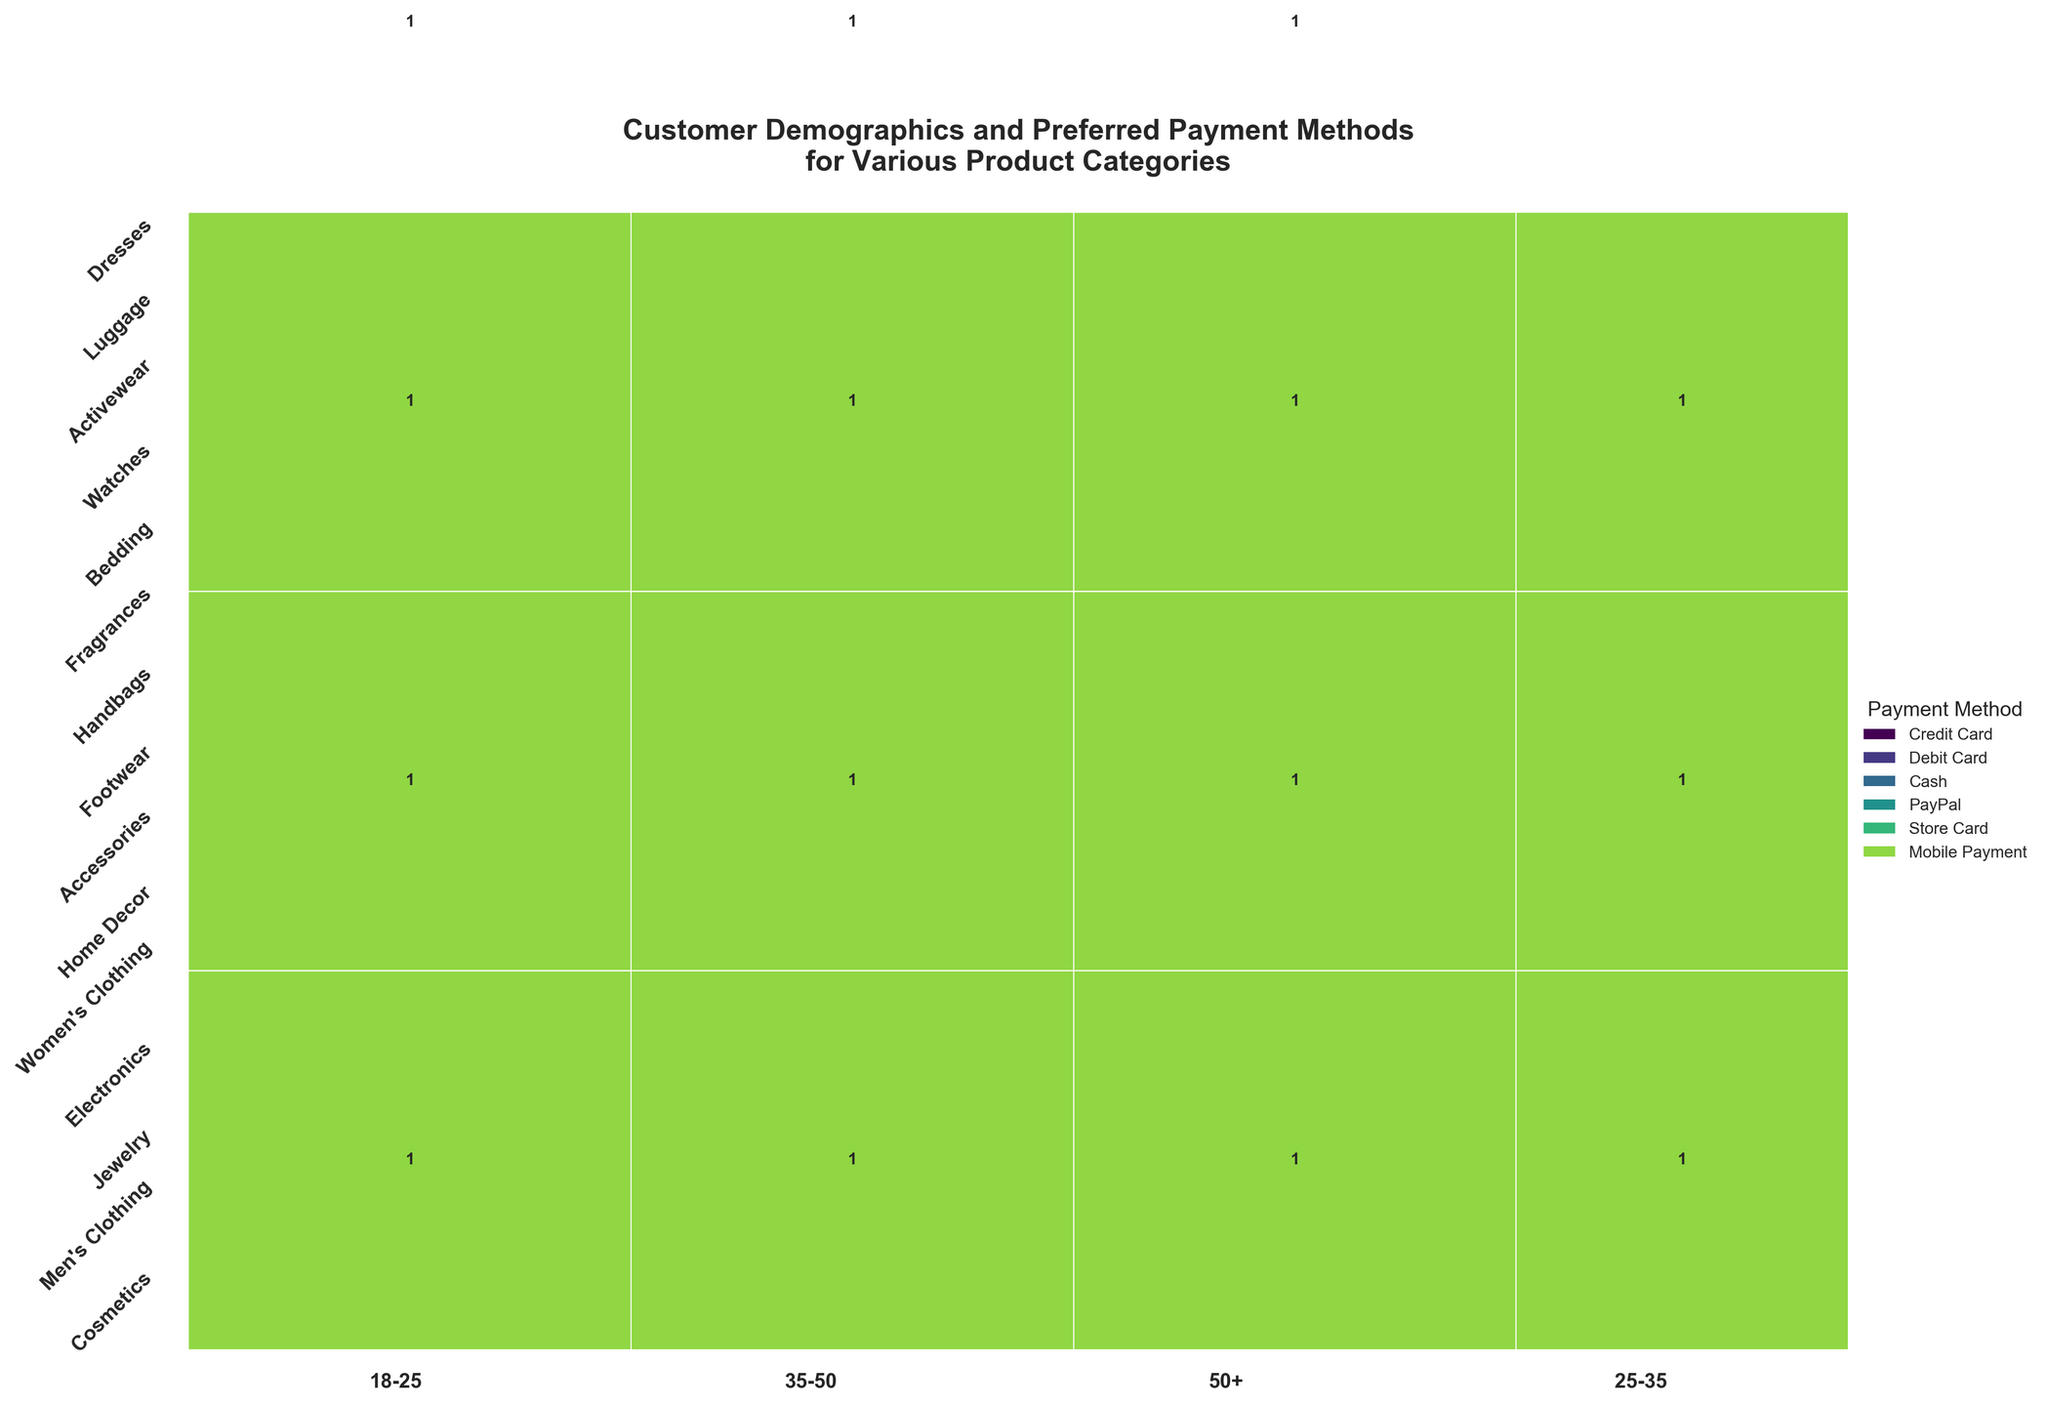How many age groups are represented in the figure? Count the unique age groups shown on the x-axis.
Answer: 4 Which payment method is indicated by the largest color block in the plot? Find the color block that occupies the most space and check the legend to see which payment method it corresponds to.
Answer: Credit Card Which product category has the most variation in payment methods? Look for the product category with the most differently colored sections within its area.
Answer: Handbags For the age group 18-25, which product category is the most purchased? Find the age group 18-25 on the x-axis and look for the product category with the largest area.
Answer: Dresses Is there any product category that a single age group dominates in terms of the area coverage? If so, which one? Check if any single age group has an overwhelmingly large area in comparison to others within a specific product category.
Answer: Yes, Electronics by the age group 25-35 Compare the payment method preference for Electronics between 25-35 age group and 35-50 age group. Which payment method is more popular? Check the color blocks' size associated with each payment method for Electronics in both 25-35 and 35-50 age groups and compare.
Answer: PayPal is more popular in 25-35 Which age group has the greatest variety of purchased product categories? Identify the age group that covers the most different product categories in its area.
Answer: 18-25 How does the pattern of payment methods for Women's Clothing compare between the age groups 35-50 and 50+? Analyze the color blocks within Women's Clothing for both age groups to identify the differences in payment method preferences.
Answer: The pattern shows a preference for Store Card in 35-50 and no payments recorded for 50+ What is the least represented product category in terms of total area covered in the plot? Look for the product category with the smallest area in the entire figure.
Answer: Fragrances Do males aged 50+ have a preference for a specific payment method? Which one? Locate the areas for males aged 50+ and analyze the relative sizes of the color blocks representing different payment methods.
Answer: Credit Card 